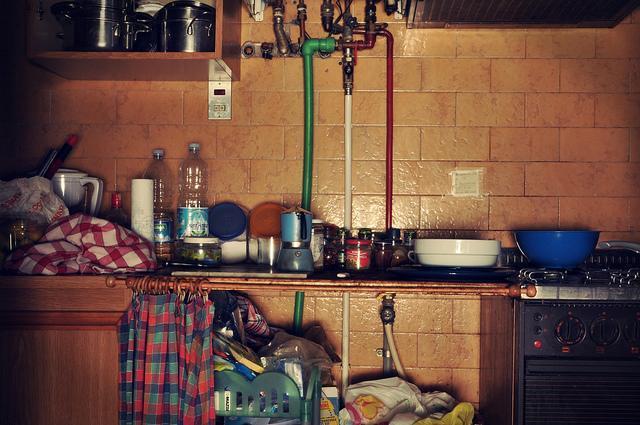How many bottles are visible?
Give a very brief answer. 2. How many bowls are there?
Give a very brief answer. 2. 